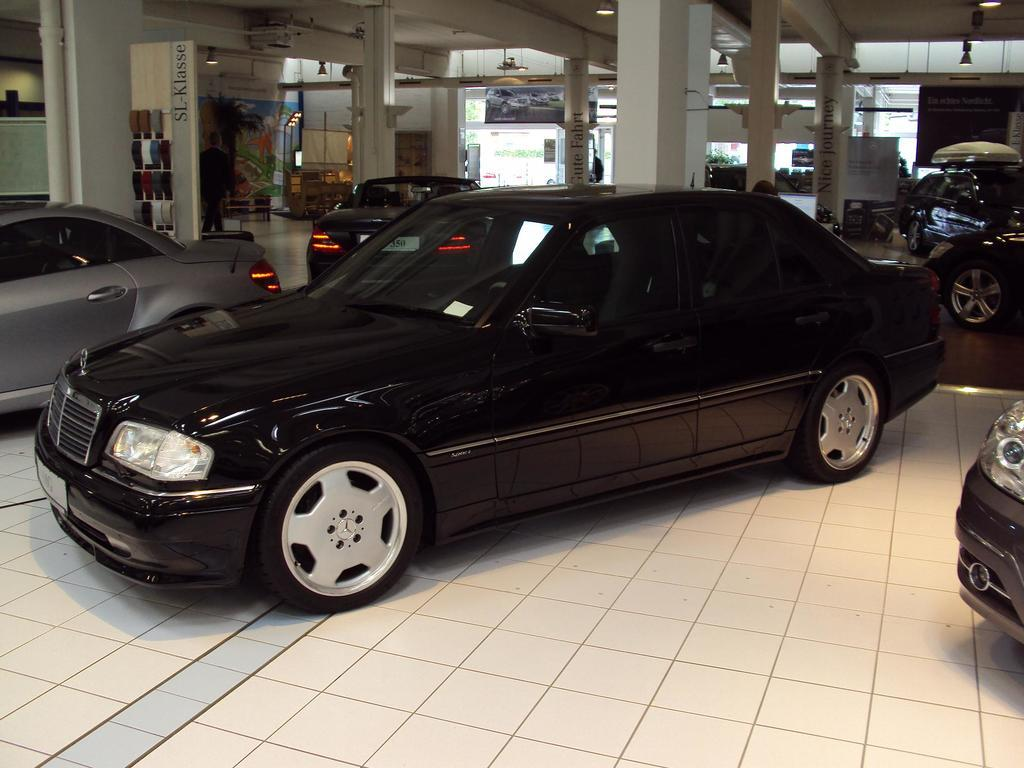What type of location is depicted in the image? The image shows an inside view of a building. What can be seen in the building? There are cars and pillars in the image. What type of approval is required for the trousers in the image? There are no trousers present in the image, so the question of approval is not applicable. 